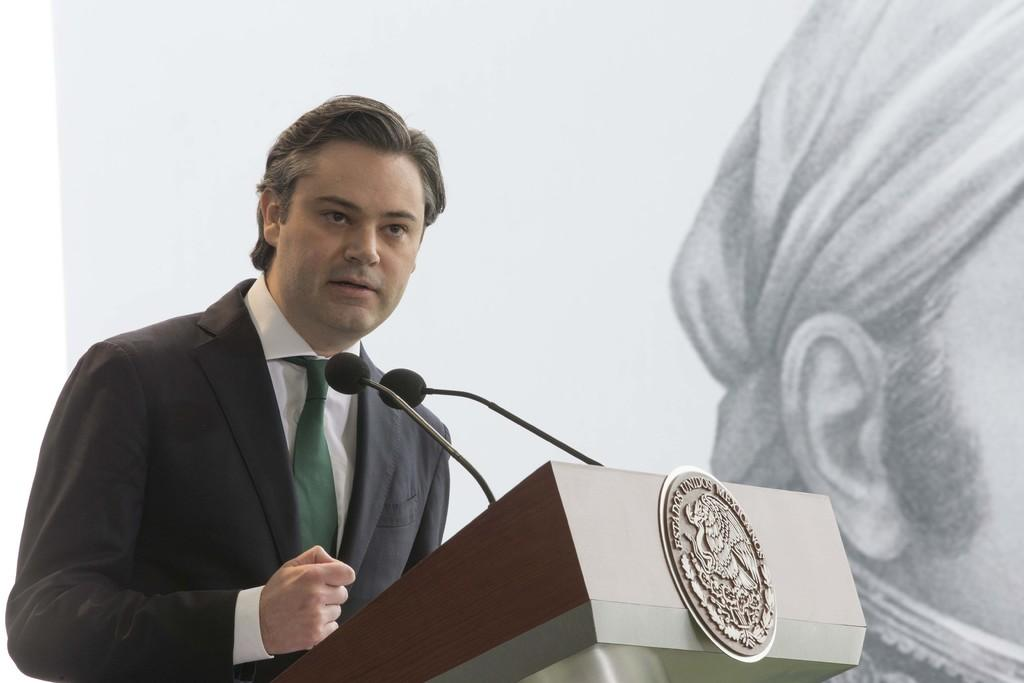What is the man in the image doing? The man is standing in front of the podium. What objects might be used for amplifying sound in the image? Microphones are present in the image. What can be seen in the background of the image? There is a depiction of a person on the wall in the background. Are there any fairies visible in the image? No, there are no fairies present in the image. What type of coil is being used by the man in the image? The image does not show any coils, and the man is not using any coil. 